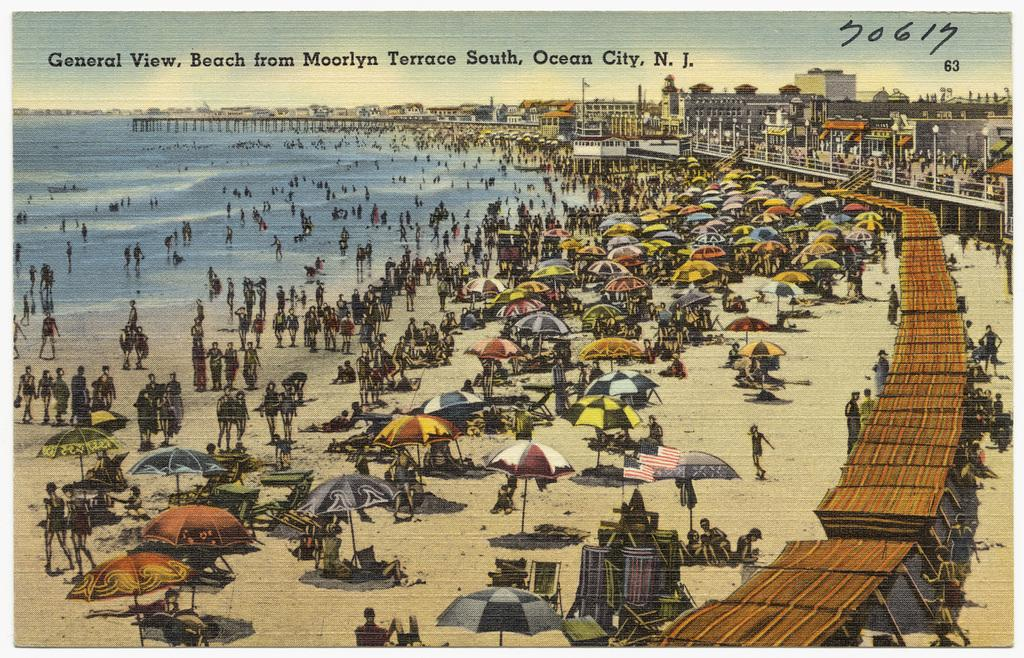<image>
Render a clear and concise summary of the photo. An old post card showing the beach from Ocean City, N.J. 